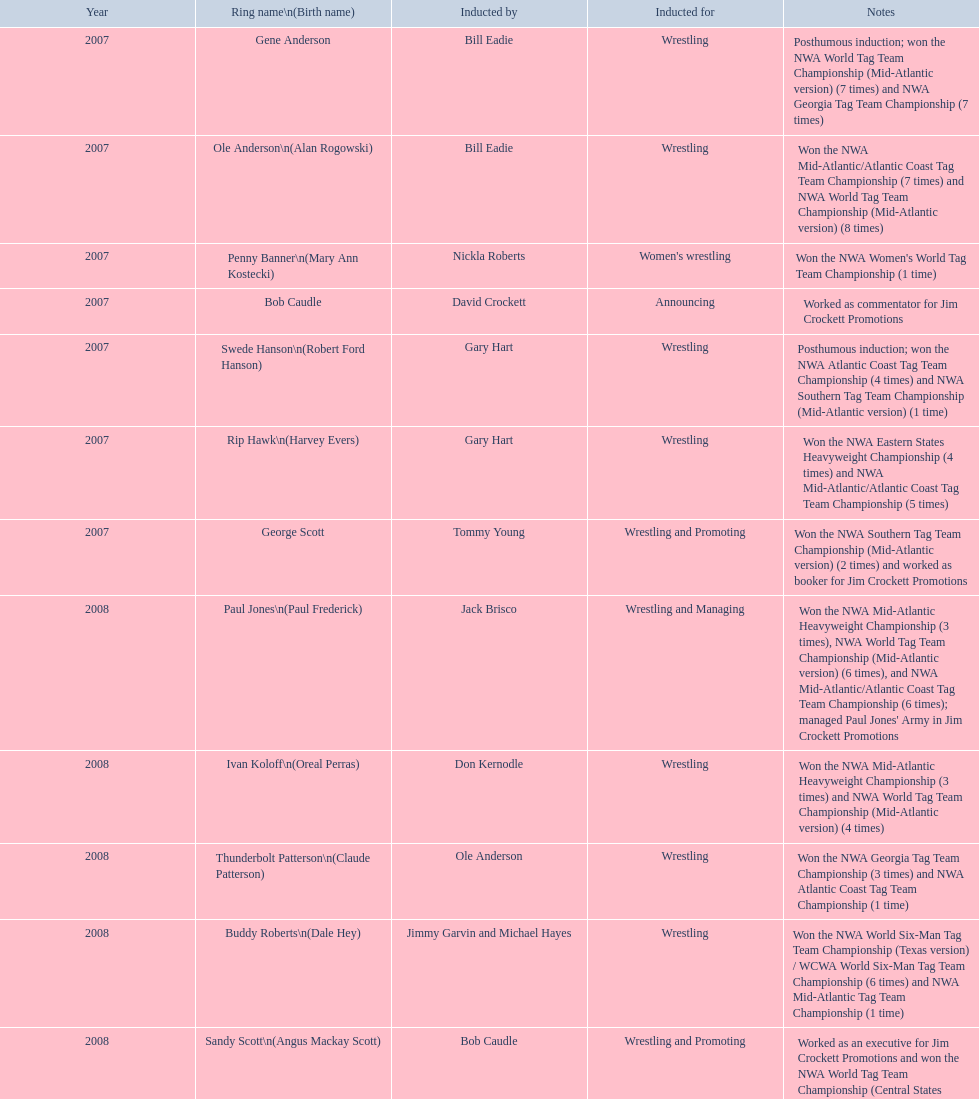For announcing, how many members were brought in? 2. 